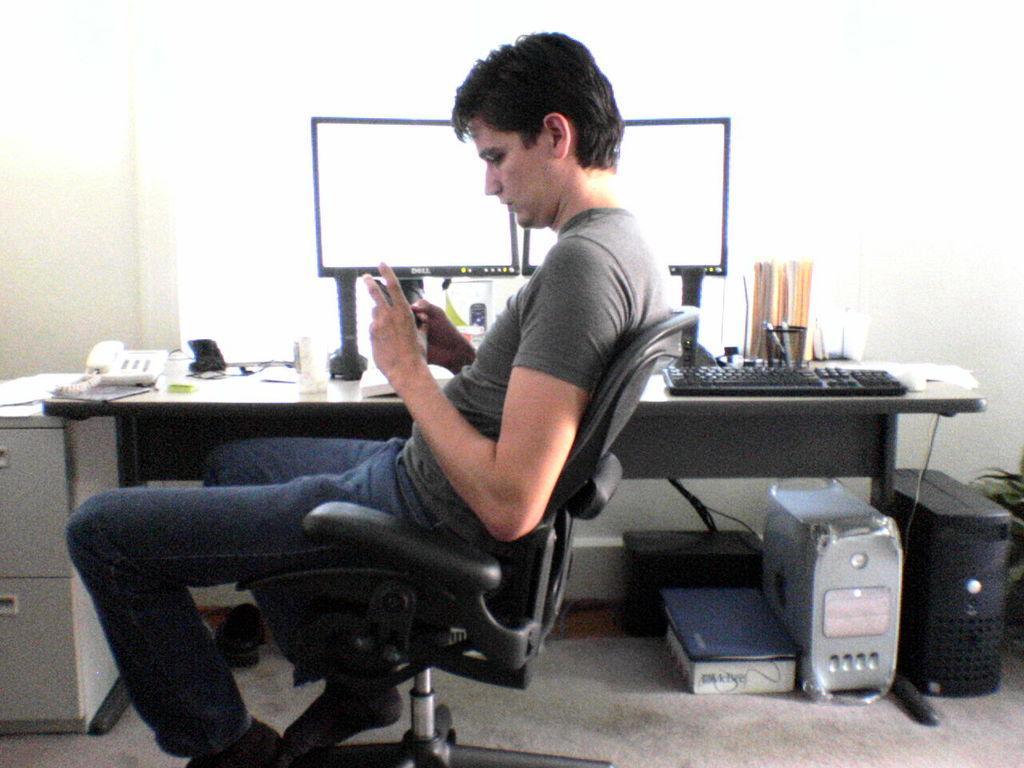Can you describe this image briefly? In the image we can see there is a man who is sitting on a black chair and beside him there is a table on which there are two monitors, a telephone, keyboard and on the ground there are two CPUs. 